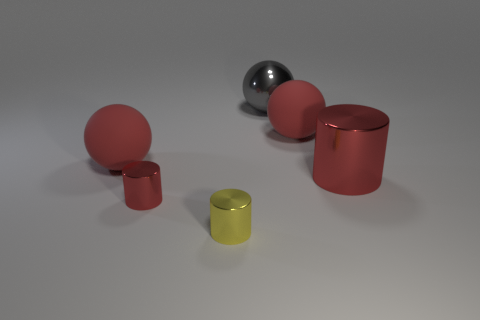There is a large rubber thing that is to the right of the big shiny thing behind the red metal cylinder on the right side of the large gray shiny sphere; what shape is it?
Your response must be concise. Sphere. How many things are either shiny things that are behind the yellow shiny cylinder or tiny things on the left side of the tiny yellow metal object?
Keep it short and to the point. 3. Are there any red metal cylinders to the right of the large red metallic thing?
Your answer should be compact. No. How many objects are red rubber balls that are to the left of the yellow shiny object or red spheres?
Your answer should be compact. 2. How many gray objects are tiny metal cylinders or spheres?
Provide a short and direct response. 1. How many other things are the same color as the big shiny cylinder?
Provide a succinct answer. 3. Are there fewer big shiny objects behind the yellow cylinder than gray objects?
Make the answer very short. No. There is a shiny object that is behind the red matte sphere that is to the right of the red object that is in front of the large red metal cylinder; what color is it?
Offer a very short reply. Gray. There is another red thing that is the same shape as the tiny red metal object; what size is it?
Offer a terse response. Large. Is the number of matte things in front of the big gray thing less than the number of large objects that are on the right side of the tiny yellow shiny object?
Provide a short and direct response. Yes. 